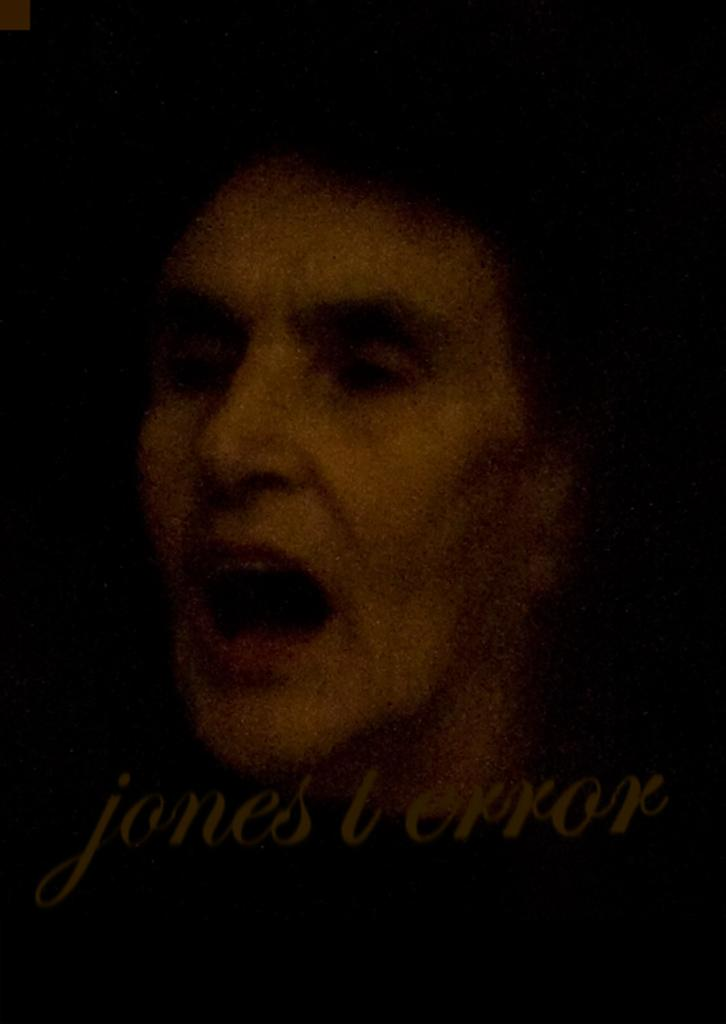What is the overall tone or appearance of the image? The image is dark. What can be seen on the person's face in the image? There is a person's face in the image. What else is visible in the image besides the person's face? There is text visible in the image. What type of paint is being used by the carpenter in the image? There is no carpenter or paint present in the image. What song is being sung by the person in the image? There is no indication of a song being sung in the image. 